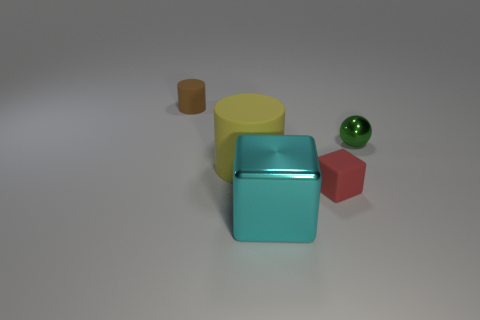The small matte thing on the right side of the big yellow matte cylinder has what shape?
Provide a short and direct response. Cube. There is a object behind the green thing; is it the same size as the large yellow rubber thing?
Provide a succinct answer. No. Is there a big object of the same color as the small cube?
Your answer should be compact. No. There is a tiny object that is in front of the yellow rubber cylinder; are there any small rubber cubes left of it?
Give a very brief answer. No. Are there any big red cubes made of the same material as the red thing?
Your answer should be compact. No. There is a big object that is on the right side of the cylinder that is in front of the tiny brown thing; what is its material?
Provide a short and direct response. Metal. What is the material of the object that is on the right side of the big rubber object and on the left side of the red matte block?
Provide a short and direct response. Metal. Are there the same number of tiny green things to the left of the green shiny sphere and tiny cylinders?
Keep it short and to the point. No. How many green things have the same shape as the small brown thing?
Give a very brief answer. 0. What size is the rubber thing to the right of the metal thing in front of the small green ball behind the tiny red rubber object?
Make the answer very short. Small. 